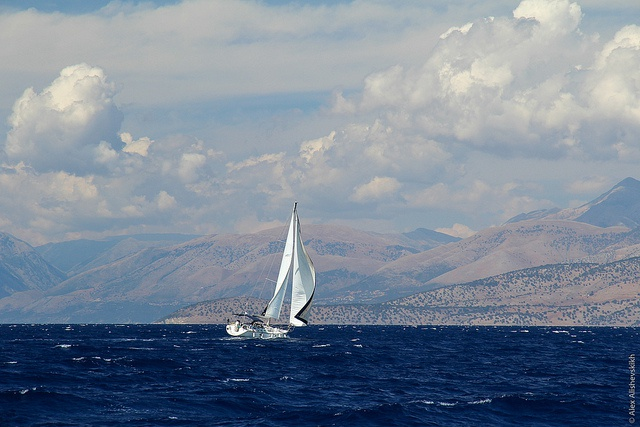Describe the objects in this image and their specific colors. I can see a boat in gray, lightgray, and darkgray tones in this image. 